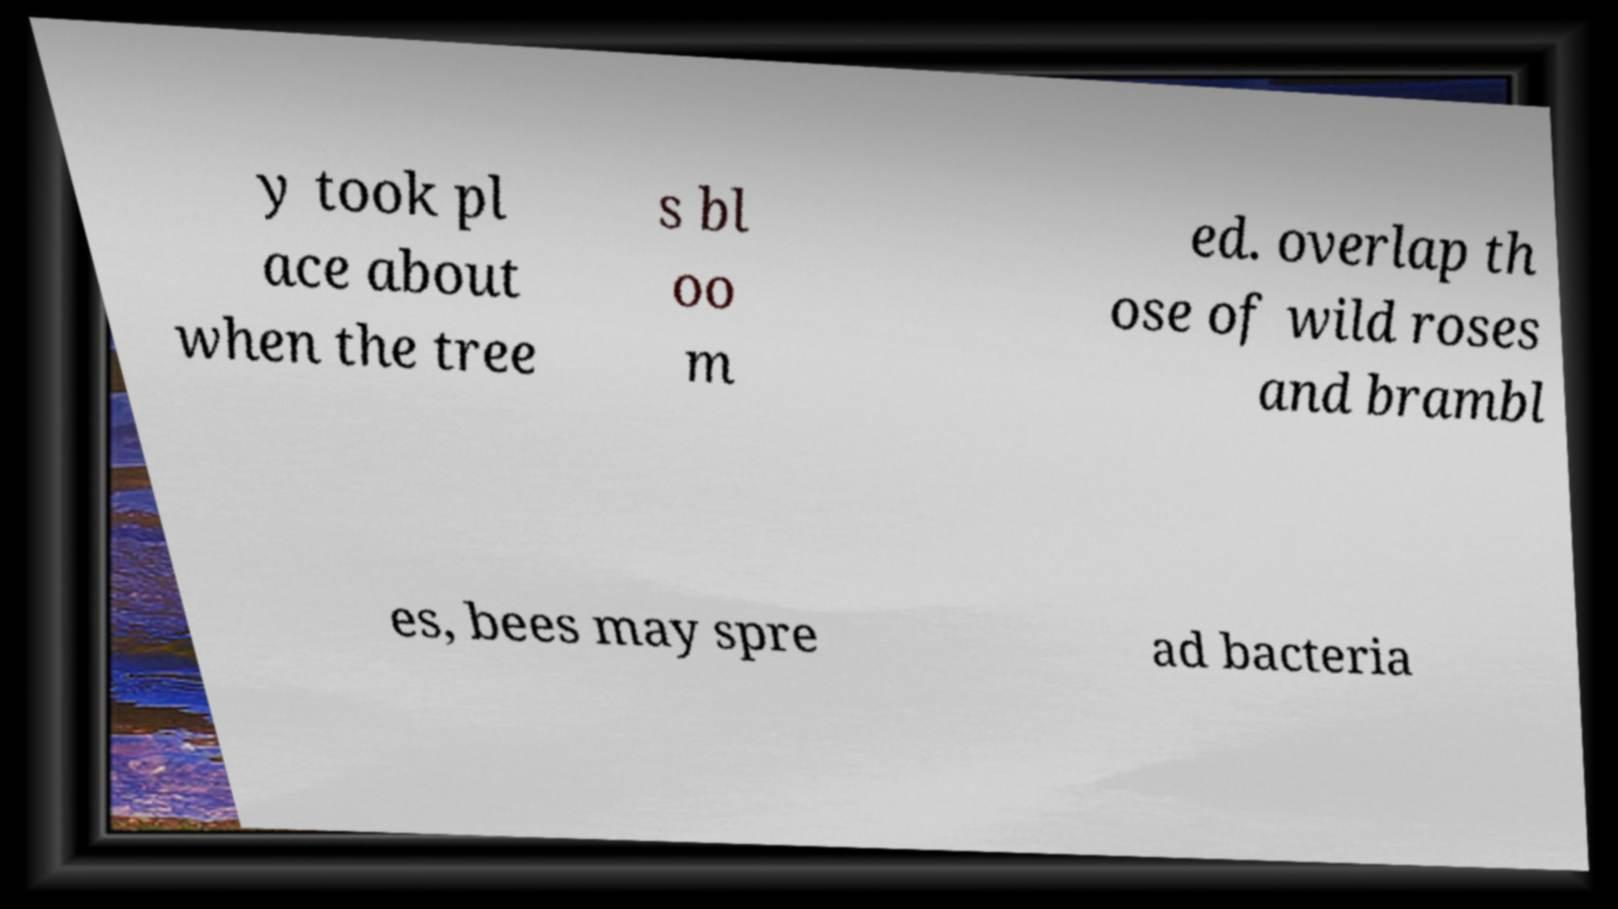For documentation purposes, I need the text within this image transcribed. Could you provide that? y took pl ace about when the tree s bl oo m ed. overlap th ose of wild roses and brambl es, bees may spre ad bacteria 